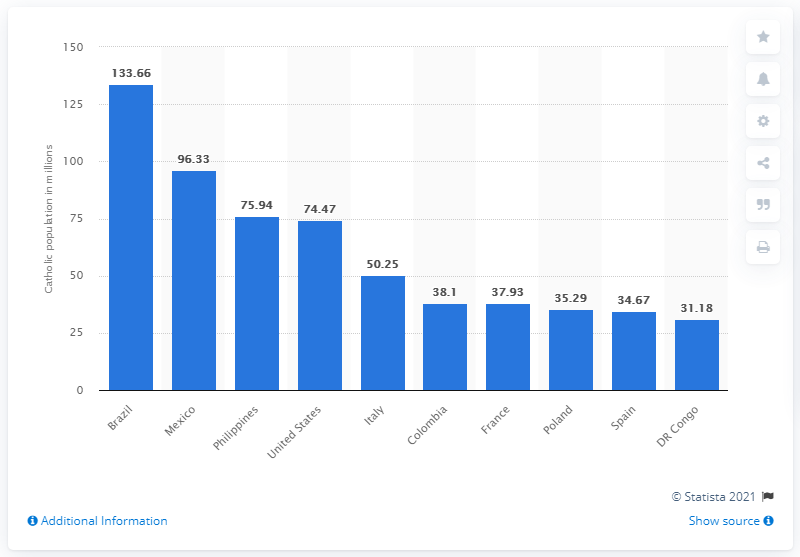Highlight a few significant elements in this photo. In 2010, it is estimated that approximately 133.66 million Catholics resided in Brazil. 